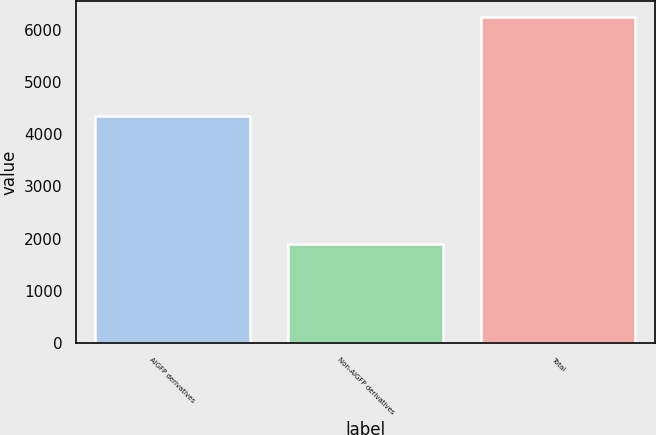Convert chart. <chart><loc_0><loc_0><loc_500><loc_500><bar_chart><fcel>AIGFP derivatives<fcel>Non-AIGFP derivatives<fcel>Total<nl><fcel>4344<fcel>1894<fcel>6238<nl></chart> 